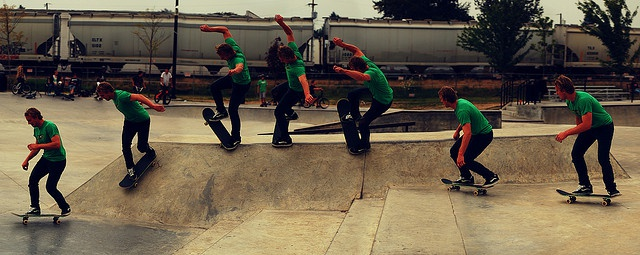Describe the objects in this image and their specific colors. I can see train in beige, black, and gray tones, people in beige, black, tan, gray, and maroon tones, people in beige, black, darkgreen, maroon, and brown tones, people in beige, black, maroon, darkgreen, and brown tones, and people in beige, black, darkgreen, maroon, and gray tones in this image. 